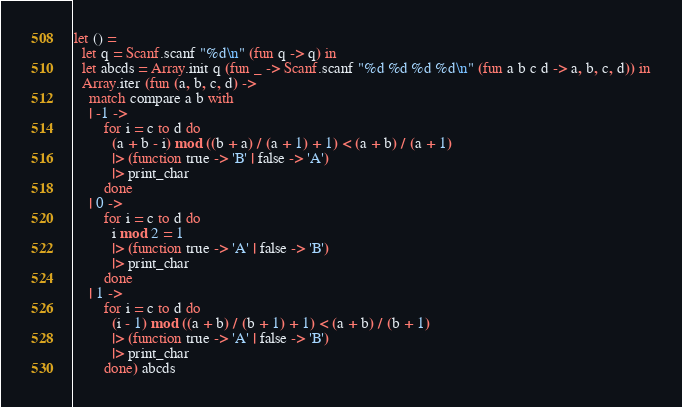Convert code to text. <code><loc_0><loc_0><loc_500><loc_500><_OCaml_>let () =
  let q = Scanf.scanf "%d\n" (fun q -> q) in
  let abcds = Array.init q (fun _ -> Scanf.scanf "%d %d %d %d\n" (fun a b c d -> a, b, c, d)) in
  Array.iter (fun (a, b, c, d) ->
    match compare a b with
    | -1 ->
        for i = c to d do
          (a + b - i) mod ((b + a) / (a + 1) + 1) < (a + b) / (a + 1)
          |> (function true -> 'B' | false -> 'A')
          |> print_char
        done
    | 0 ->
        for i = c to d do
          i mod 2 = 1
          |> (function true -> 'A' | false -> 'B')
          |> print_char
        done
    | 1 ->
        for i = c to d do
          (i - 1) mod ((a + b) / (b + 1) + 1) < (a + b) / (b + 1)
          |> (function true -> 'A' | false -> 'B')
          |> print_char
        done) abcds</code> 